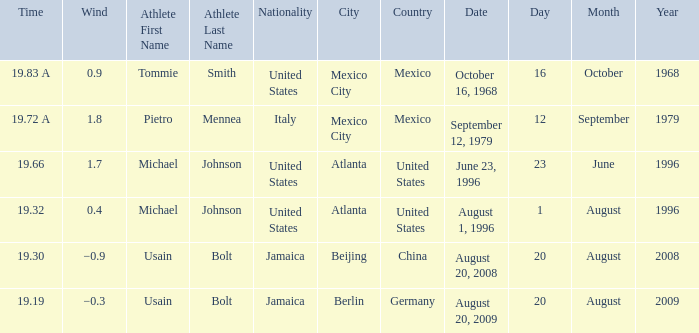What's the wind when the time was 19.32? 0.4. 